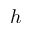Convert formula to latex. <formula><loc_0><loc_0><loc_500><loc_500>h</formula> 